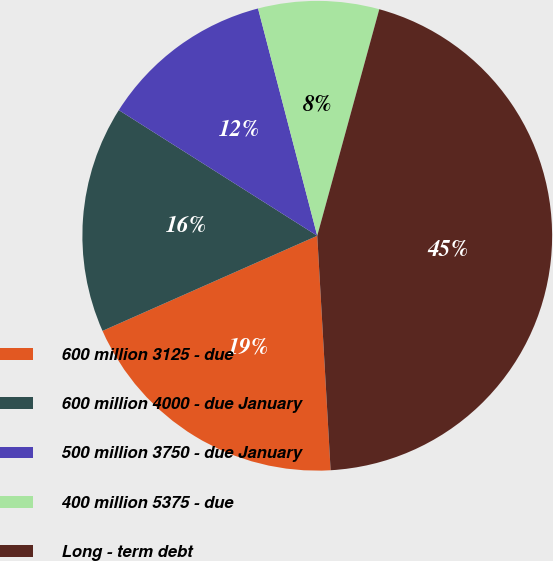Convert chart to OTSL. <chart><loc_0><loc_0><loc_500><loc_500><pie_chart><fcel>600 million 3125 - due<fcel>600 million 4000 - due January<fcel>500 million 3750 - due January<fcel>400 million 5375 - due<fcel>Long - term debt<nl><fcel>19.27%<fcel>15.62%<fcel>11.96%<fcel>8.31%<fcel>44.84%<nl></chart> 